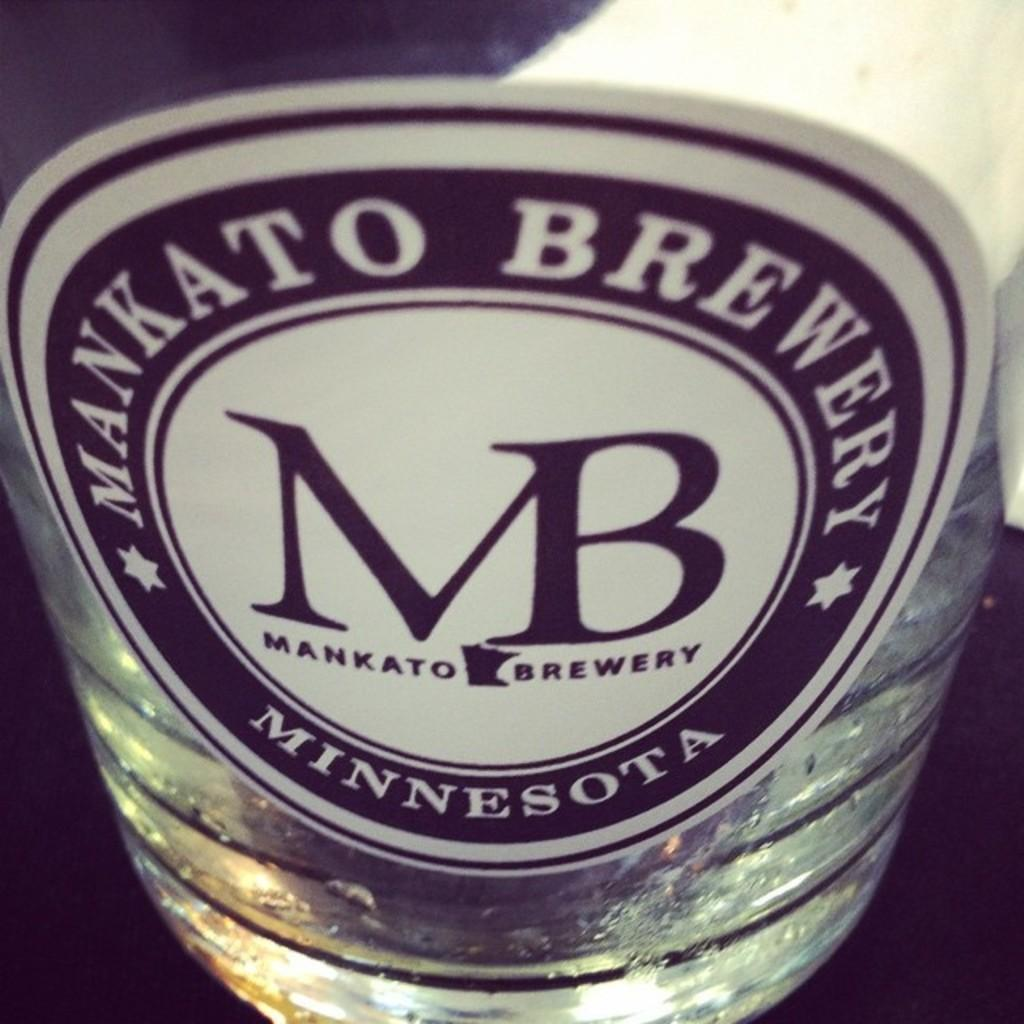<image>
Summarize the visual content of the image. a bottle of mankato brewery from minnesota partly filled 